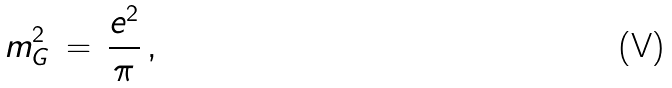<formula> <loc_0><loc_0><loc_500><loc_500>m ^ { 2 } _ { G } \, = \, \frac { e ^ { 2 } } { \pi } \, ,</formula> 